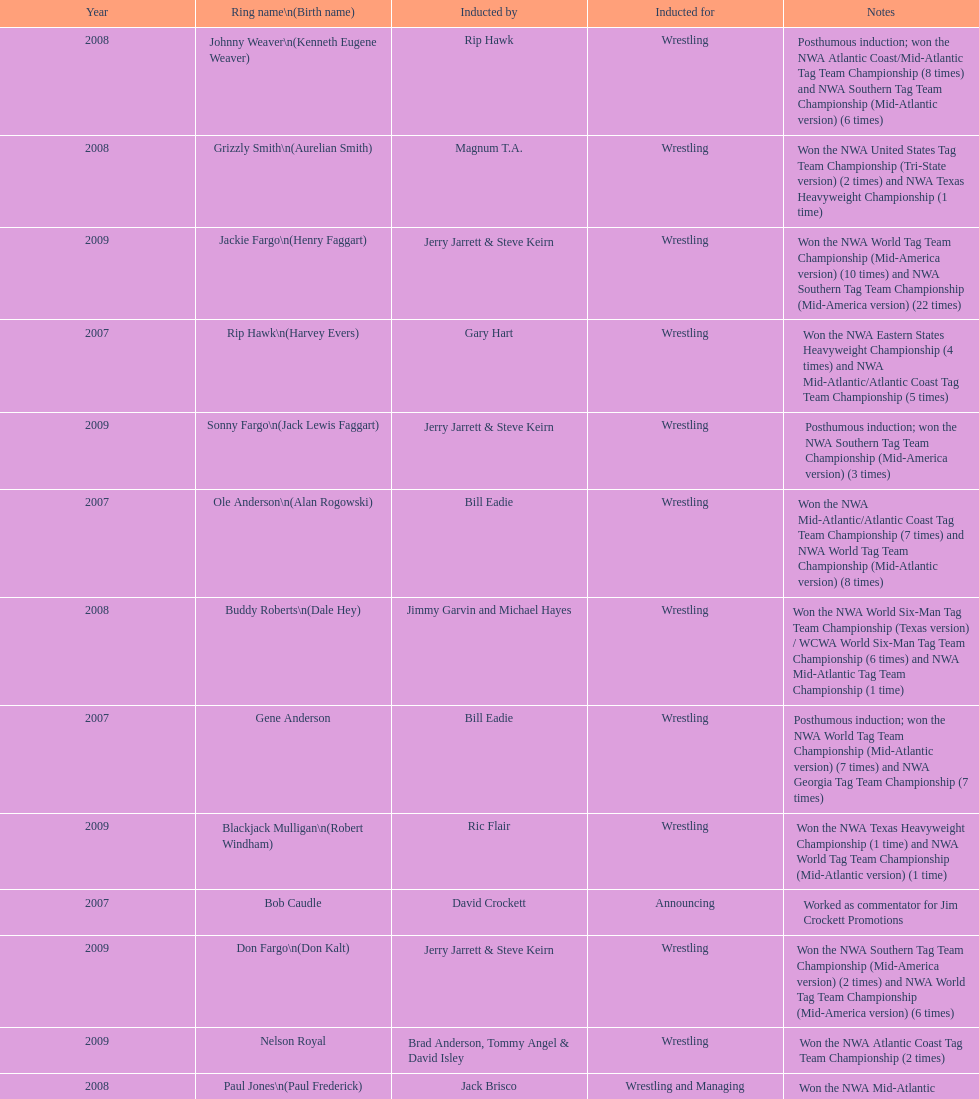Who was inducted after royal? Lance Russell. 